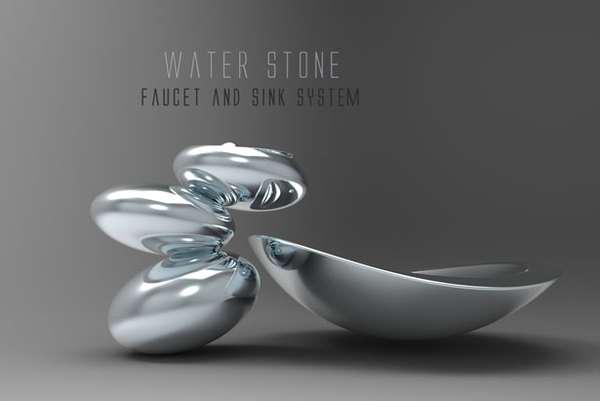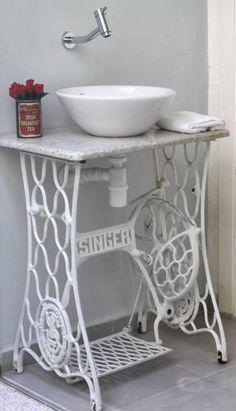The first image is the image on the left, the second image is the image on the right. For the images shown, is this caption "In exactly one image water is pouring from the faucet." true? Answer yes or no. No. 